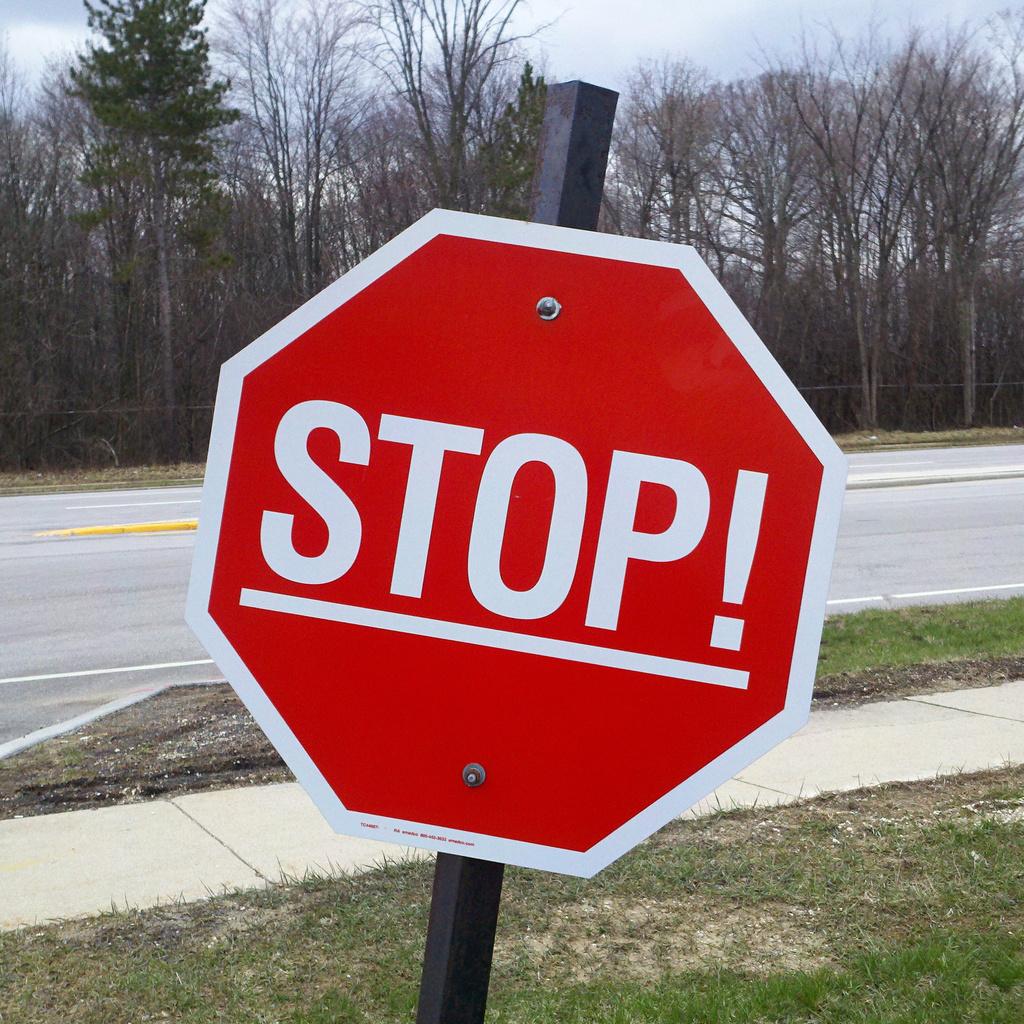What direction is the sign giving?
Offer a terse response. Stop. What word in underlined on the sign?
Your response must be concise. Stop. 